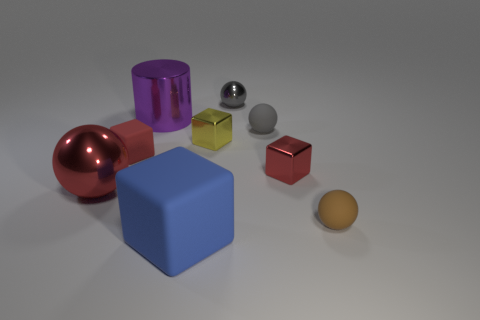Is there anything else that is the same shape as the purple shiny thing?
Offer a terse response. No. What shape is the tiny matte object that is on the left side of the small gray metal sphere?
Provide a short and direct response. Cube. What is the material of the blue block that is the same size as the purple metal object?
Your answer should be very brief. Rubber. What number of things are objects behind the large block or objects in front of the red shiny ball?
Your response must be concise. 9. What size is the blue thing that is made of the same material as the small brown sphere?
Keep it short and to the point. Large. How many matte things are big cylinders or small gray objects?
Your response must be concise. 1. How big is the blue matte cube?
Your answer should be very brief. Large. Is the size of the red matte thing the same as the yellow metallic object?
Provide a short and direct response. Yes. There is a large object that is behind the big ball; what material is it?
Provide a succinct answer. Metal. There is a large object that is the same shape as the small gray metal thing; what is its material?
Provide a short and direct response. Metal. 